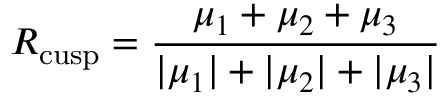<formula> <loc_0><loc_0><loc_500><loc_500>R _ { c u s p } = \frac { \mu _ { 1 } + \mu _ { 2 } + \mu _ { 3 } } { | \mu _ { 1 } | + | \mu _ { 2 } | + | \mu _ { 3 } | }</formula> 